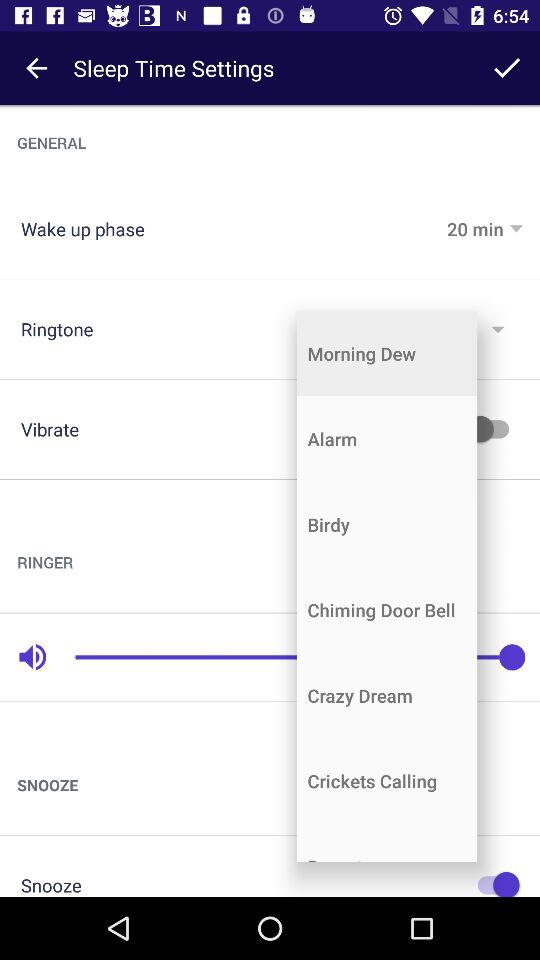What is the status of "Vibrate"? The status is "off". 